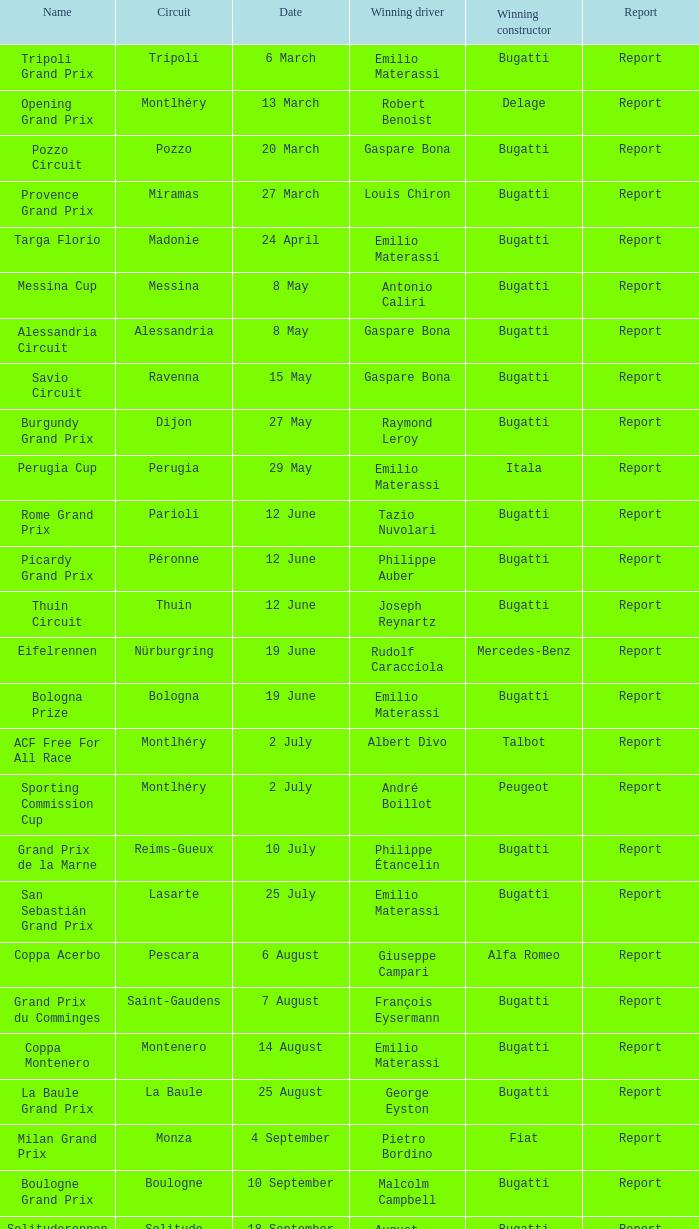On which circuit was françois eysermann the winner? Saint-Gaudens. 